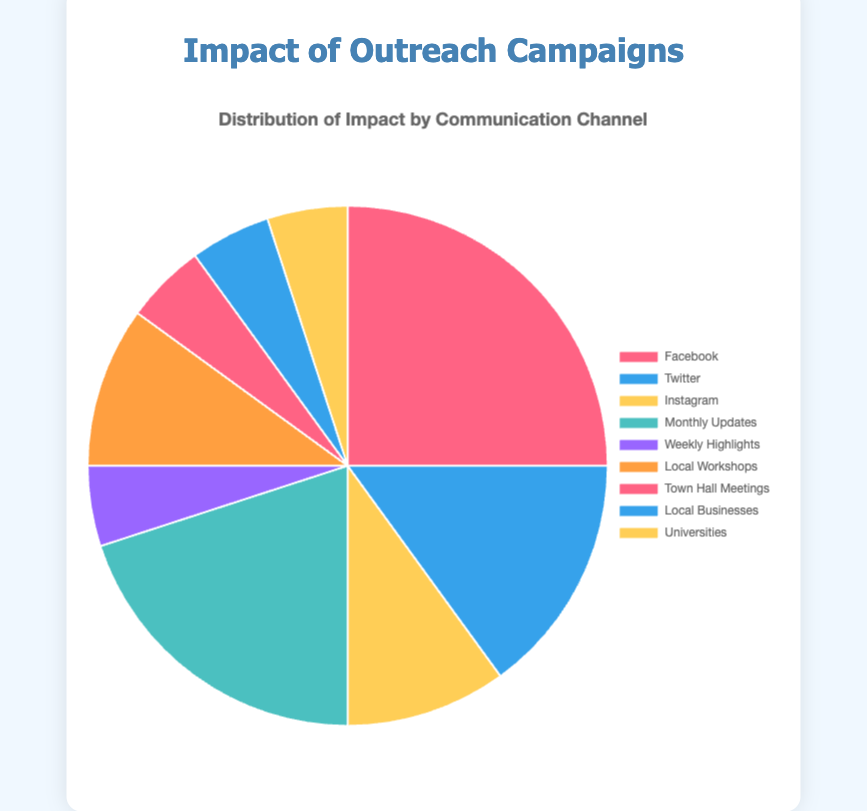Which communication channel has the highest impact? Looking at the chart, it's clear that the largest segment corresponds to Facebook with 25%.
Answer: Facebook What percentage of the impact is from social media channels combined? Adding up the percentages of Facebook (25%), Twitter (15%), and Instagram (10%) gives a total of 50%.
Answer: 50% Which entity in the Community Events channel has a greater impact? Community Events include Local Workshops (10%) and Town Hall Meetings (5%). Local Workshops have a greater impact.
Answer: Local Workshops How does the impact of Monthly Updates compare to Weekly Highlights? Monthly Updates contribute 20% while Weekly Highlights contribute 5%. Monthly Updates have a significantly larger impact.
Answer: Monthly Updates What is the combined impact of all entities within the Partnerships channel? Adding the percentages for Local Businesses (5%) and Universities (5%) results in a combined impact of 10%.
Answer: 10% Is the impact of Instagram greater than that of Town Hall Meetings? Instagram has a 10% impact while Town Hall Meetings have a 5% impact. Instagram's impact is greater.
Answer: Yes What visual attribute distinguishes the impact of Facebook from that of Universities? The segment for Facebook is larger and has a different color (red for Facebook and yellow for Universities).
Answer: Segment size and color Between Social Media and Community Events channels, which one has a higher combined impact? Social Media totals 50% (Facebook 25%, Twitter 15%, Instagram 10%) while Community Events totals 15% (Local Workshops 10%, Town Hall Meetings 5%). Social Media has a higher combined impact.
Answer: Social Media What is the average impact of the entities within the Email Newsletters channel? The entities are Monthly Updates (20%) and Weekly Highlights (5%). The average is (20 + 5) / 2 = 12.5%.
Answer: 12.5% What is the difference in impact percentage between the most impactful and least impactful entities? The most impactful entity is Facebook with 25%, and the least impactful entities are Weekly Highlights, Town Hall Meetings, Local Businesses, and Universities, each with 5%. The difference is 25 - 5 = 20%.
Answer: 20% 